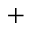<formula> <loc_0><loc_0><loc_500><loc_500>^ { + }</formula> 